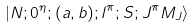Convert formula to latex. <formula><loc_0><loc_0><loc_500><loc_500>| N ; 0 ^ { \eta } ; ( a , b ) ; l ^ { \pi } ; S ; J ^ { \pi } M _ { J } \rangle</formula> 